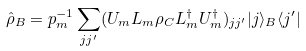<formula> <loc_0><loc_0><loc_500><loc_500>\hat { \rho } _ { B } = p _ { m } ^ { - 1 } \sum _ { j j ^ { \prime } } ( U _ { m } L _ { m } \rho _ { C } L _ { m } ^ { \dag } U _ { m } ^ { \dag } ) _ { j j ^ { \prime } } | j \rangle _ { B } \langle j ^ { \prime } |</formula> 